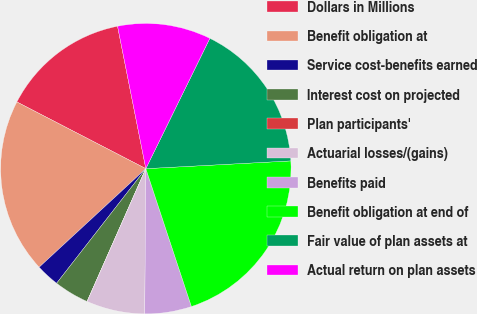<chart> <loc_0><loc_0><loc_500><loc_500><pie_chart><fcel>Dollars in Millions<fcel>Benefit obligation at<fcel>Service cost-benefits earned<fcel>Interest cost on projected<fcel>Plan participants'<fcel>Actuarial losses/(gains)<fcel>Benefits paid<fcel>Benefit obligation at end of<fcel>Fair value of plan assets at<fcel>Actual return on plan assets<nl><fcel>14.28%<fcel>19.47%<fcel>2.6%<fcel>3.9%<fcel>0.01%<fcel>6.5%<fcel>5.2%<fcel>20.77%<fcel>16.88%<fcel>10.39%<nl></chart> 